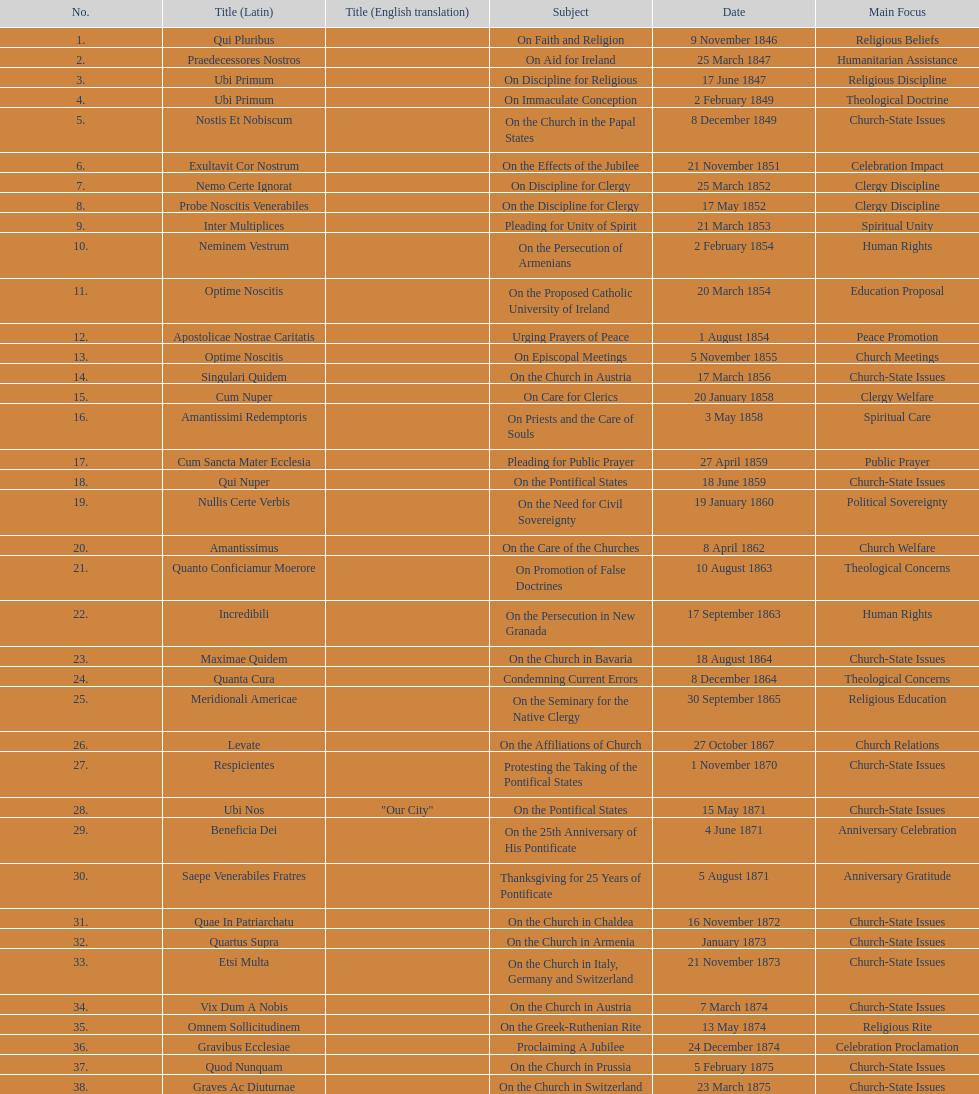What is the last title? Graves Ac Diuturnae. 